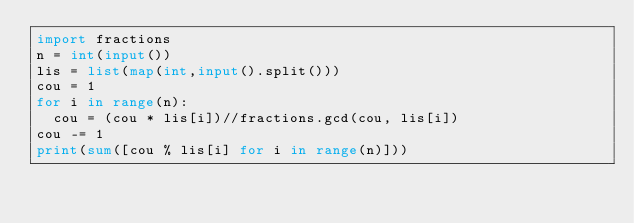<code> <loc_0><loc_0><loc_500><loc_500><_Python_>import fractions
n = int(input())
lis = list(map(int,input().split()))
cou = 1
for i in range(n):
  cou = (cou * lis[i])//fractions.gcd(cou, lis[i])
cou -= 1
print(sum([cou % lis[i] for i in range(n)]))</code> 